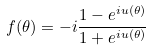Convert formula to latex. <formula><loc_0><loc_0><loc_500><loc_500>f ( \theta ) = - i \frac { 1 - e ^ { i u ( \theta ) } } { 1 + e ^ { i u ( \theta ) } }</formula> 